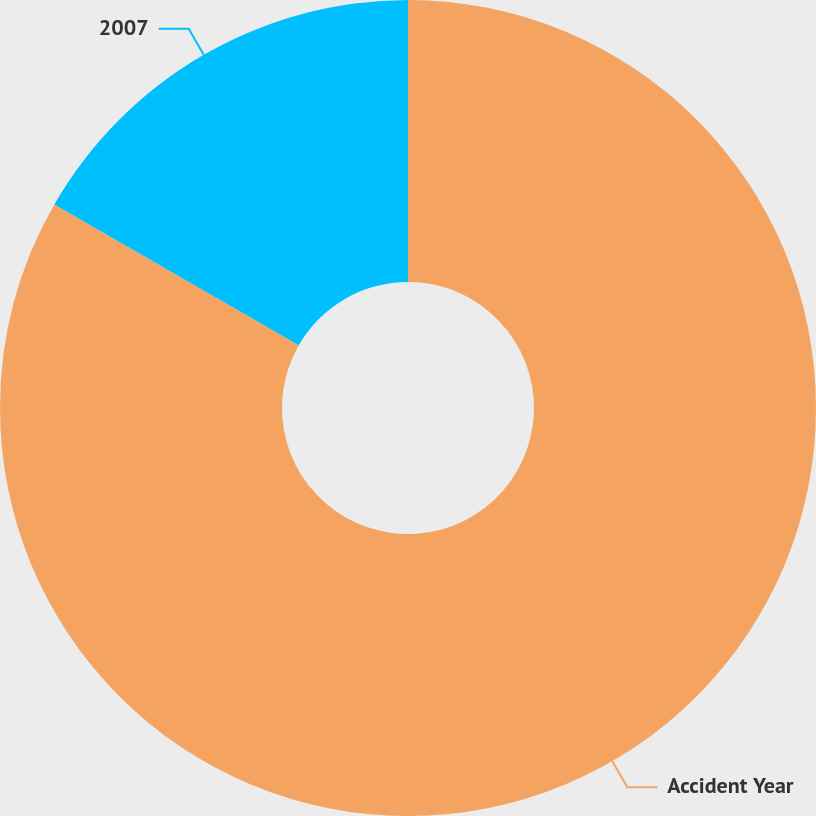Convert chart to OTSL. <chart><loc_0><loc_0><loc_500><loc_500><pie_chart><fcel>Accident Year<fcel>2007<nl><fcel>83.31%<fcel>16.69%<nl></chart> 